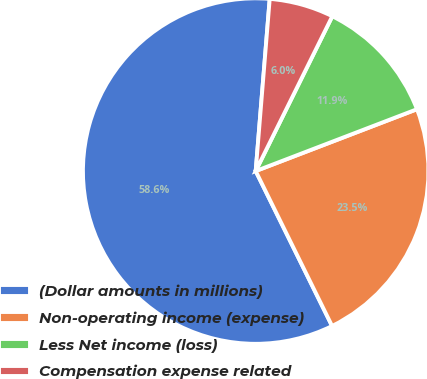Convert chart to OTSL. <chart><loc_0><loc_0><loc_500><loc_500><pie_chart><fcel>(Dollar amounts in millions)<fcel>Non-operating income (expense)<fcel>Less Net income (loss)<fcel>Compensation expense related<nl><fcel>58.59%<fcel>23.54%<fcel>11.86%<fcel>6.02%<nl></chart> 